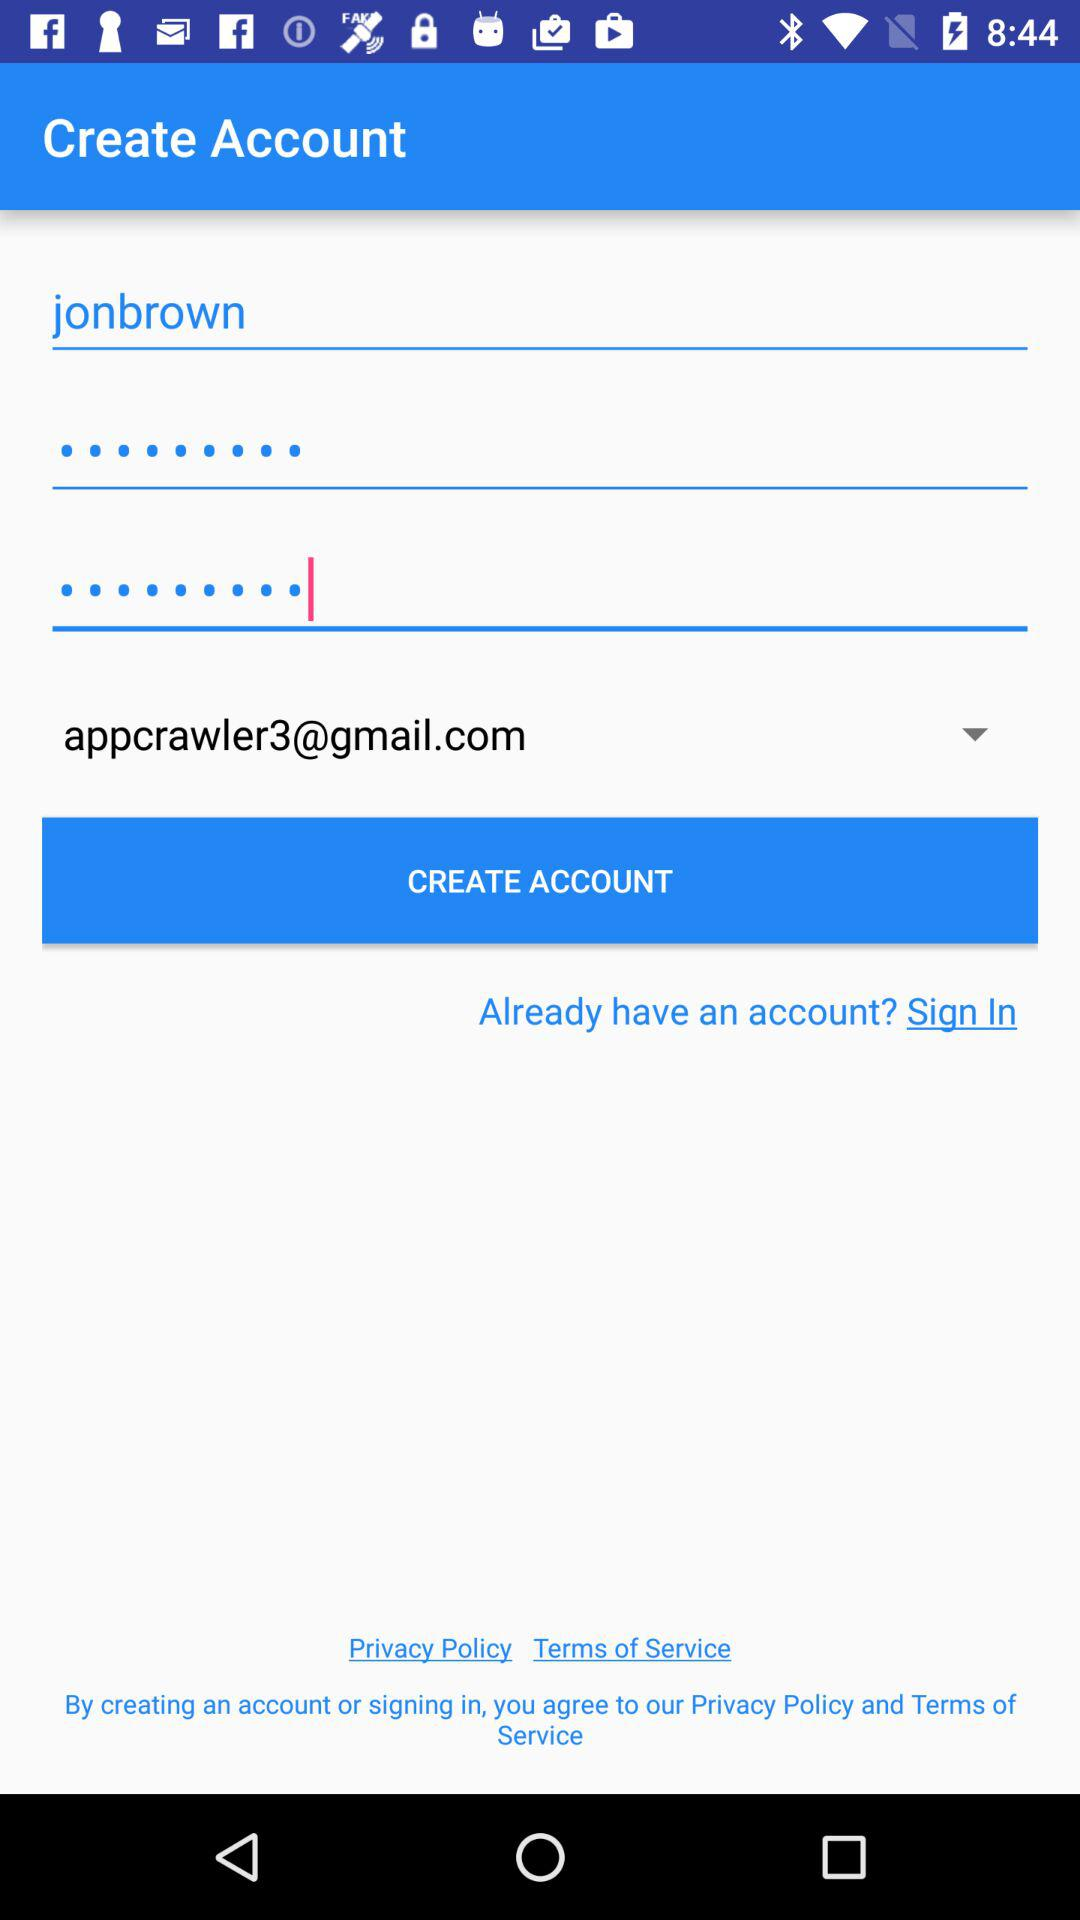What is the user name? The user name is jonbrown. 